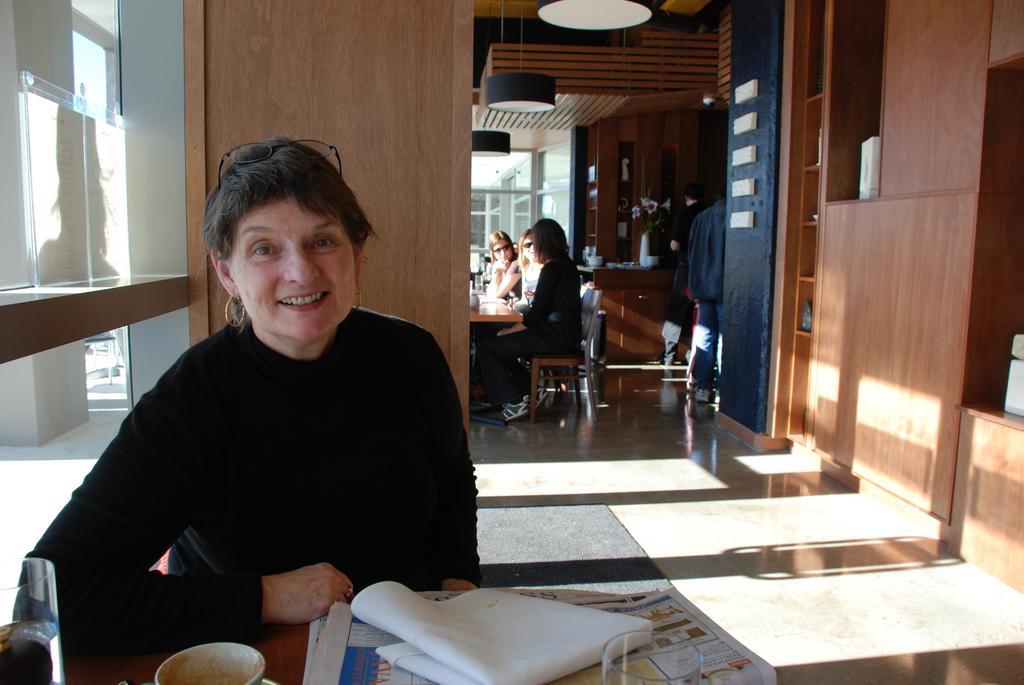How would you summarize this image in a sentence or two? On the background we can see windows. Here we can see persons standing. This is a flower vase on the table. Here we can see women sitting on chairs in front of a table a. This is a floor. Here we can see one women smiling , wearing a black colour full sleeve length shirt sitting in front of a table and on the table we can see a white cloth, news paper, glass, cup and saucer and a glass with drink in it. 